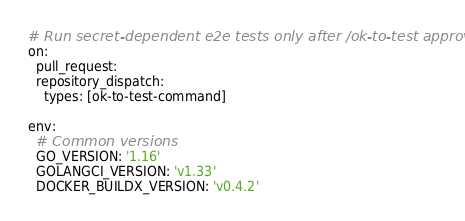Convert code to text. <code><loc_0><loc_0><loc_500><loc_500><_YAML_># Run secret-dependent e2e tests only after /ok-to-test approval
on:
  pull_request:
  repository_dispatch:
    types: [ok-to-test-command]

env:
  # Common versions
  GO_VERSION: '1.16'
  GOLANGCI_VERSION: 'v1.33'
  DOCKER_BUILDX_VERSION: 'v0.4.2'
</code> 